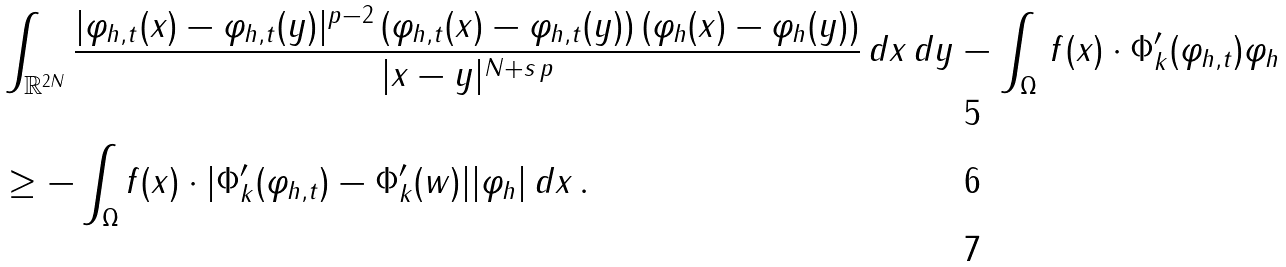<formula> <loc_0><loc_0><loc_500><loc_500>& \int _ { \mathbb { R } ^ { 2 N } } \frac { | \varphi _ { h , t } ( x ) - \varphi _ { h , t } ( y ) | ^ { p - 2 } \, ( \varphi _ { h , t } ( x ) - \varphi _ { h , t } ( y ) ) \, ( \varphi _ { h } ( x ) - \varphi _ { h } ( y ) ) } { | x - y | ^ { N + s \, p } } \, d x \, d y - \int _ { \Omega } \, f ( x ) \cdot \Phi _ { k } ^ { \prime } ( \varphi _ { h , t } ) \varphi _ { h } \\ & \geq - \int _ { \Omega } f ( x ) \cdot | \Phi _ { k } ^ { \prime } ( \varphi _ { h , t } ) - \Phi _ { k } ^ { \prime } ( w ) | | \varphi _ { h } | \, d x \, . \\</formula> 